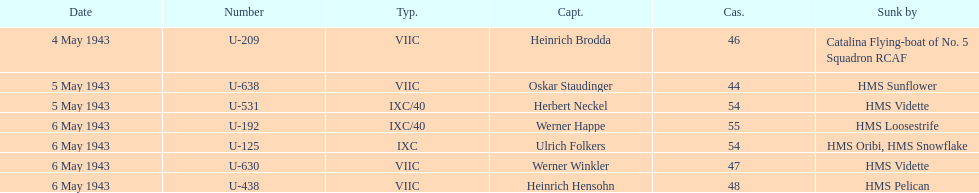How many more casualties occurred on may 6 compared to may 4? 158. 